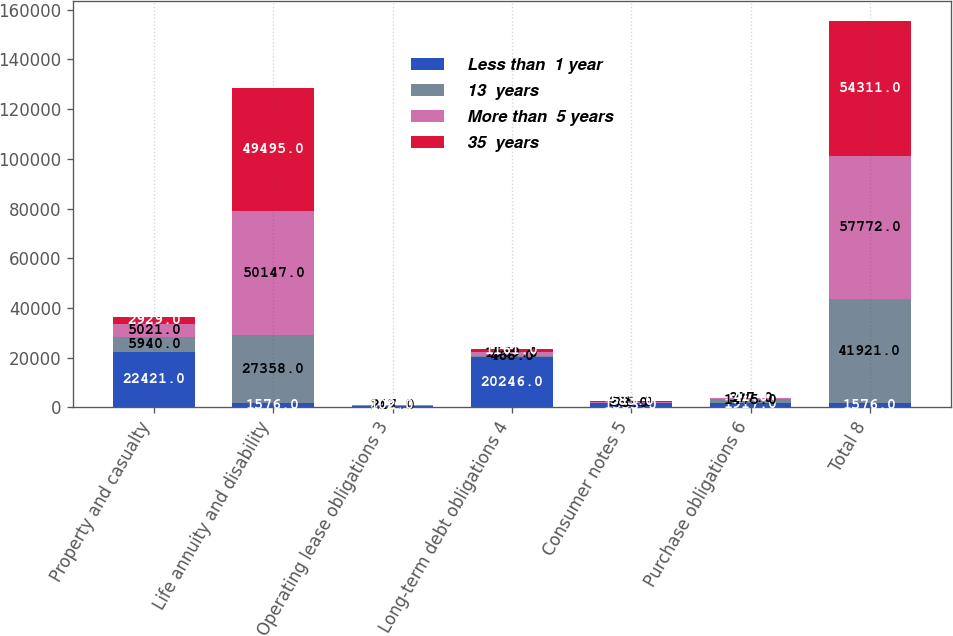Convert chart to OTSL. <chart><loc_0><loc_0><loc_500><loc_500><stacked_bar_chart><ecel><fcel>Property and casualty<fcel>Life annuity and disability<fcel>Operating lease obligations 3<fcel>Long-term debt obligations 4<fcel>Consumer notes 5<fcel>Purchase obligations 6<fcel>Total 8<nl><fcel>Less than  1 year<fcel>22421<fcel>1576<fcel>498<fcel>20246<fcel>1583<fcel>1917<fcel>1576<nl><fcel>13  years<fcel>5940<fcel>27358<fcel>143<fcel>468<fcel>73<fcel>1475<fcel>41921<nl><fcel>More than  5 years<fcel>5021<fcel>50147<fcel>217<fcel>1569<fcel>285<fcel>377<fcel>57772<nl><fcel>35  years<fcel>2929<fcel>49495<fcel>102<fcel>1161<fcel>583<fcel>41<fcel>54311<nl></chart> 